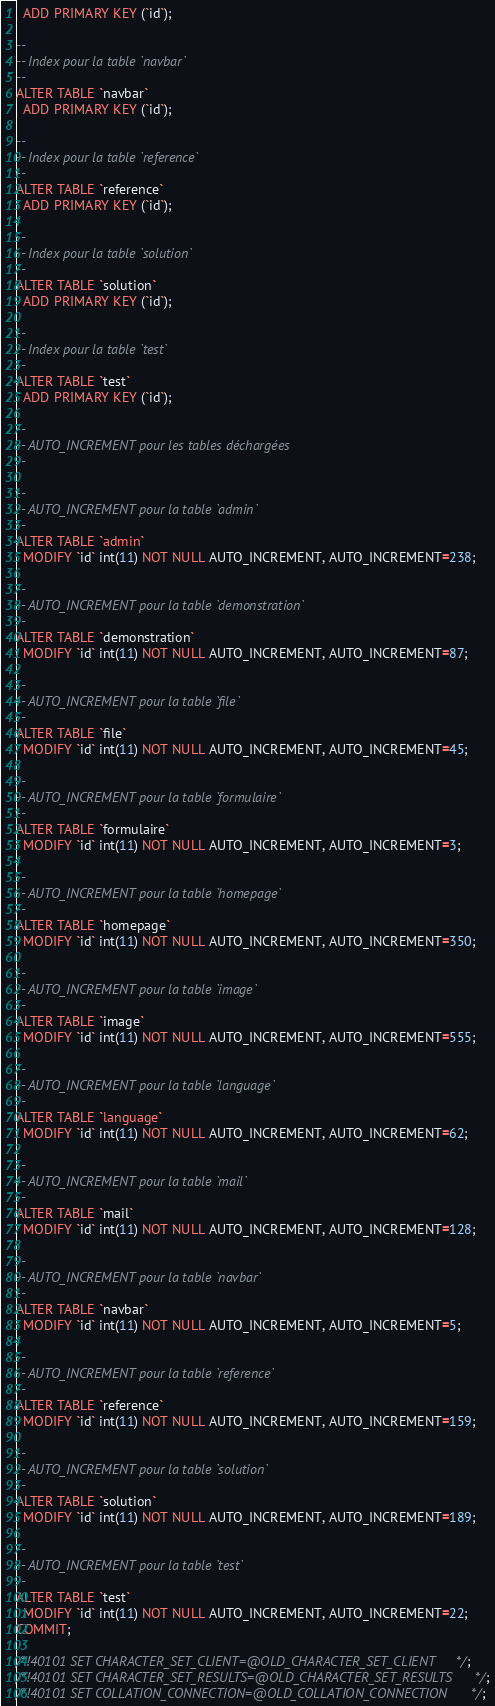<code> <loc_0><loc_0><loc_500><loc_500><_SQL_>  ADD PRIMARY KEY (`id`);

--
-- Index pour la table `navbar`
--
ALTER TABLE `navbar`
  ADD PRIMARY KEY (`id`);

--
-- Index pour la table `reference`
--
ALTER TABLE `reference`
  ADD PRIMARY KEY (`id`);

--
-- Index pour la table `solution`
--
ALTER TABLE `solution`
  ADD PRIMARY KEY (`id`);

--
-- Index pour la table `test`
--
ALTER TABLE `test`
  ADD PRIMARY KEY (`id`);

--
-- AUTO_INCREMENT pour les tables déchargées
--

--
-- AUTO_INCREMENT pour la table `admin`
--
ALTER TABLE `admin`
  MODIFY `id` int(11) NOT NULL AUTO_INCREMENT, AUTO_INCREMENT=238;

--
-- AUTO_INCREMENT pour la table `demonstration`
--
ALTER TABLE `demonstration`
  MODIFY `id` int(11) NOT NULL AUTO_INCREMENT, AUTO_INCREMENT=87;

--
-- AUTO_INCREMENT pour la table `file`
--
ALTER TABLE `file`
  MODIFY `id` int(11) NOT NULL AUTO_INCREMENT, AUTO_INCREMENT=45;

--
-- AUTO_INCREMENT pour la table `formulaire`
--
ALTER TABLE `formulaire`
  MODIFY `id` int(11) NOT NULL AUTO_INCREMENT, AUTO_INCREMENT=3;

--
-- AUTO_INCREMENT pour la table `homepage`
--
ALTER TABLE `homepage`
  MODIFY `id` int(11) NOT NULL AUTO_INCREMENT, AUTO_INCREMENT=350;

--
-- AUTO_INCREMENT pour la table `image`
--
ALTER TABLE `image`
  MODIFY `id` int(11) NOT NULL AUTO_INCREMENT, AUTO_INCREMENT=555;

--
-- AUTO_INCREMENT pour la table `language`
--
ALTER TABLE `language`
  MODIFY `id` int(11) NOT NULL AUTO_INCREMENT, AUTO_INCREMENT=62;

--
-- AUTO_INCREMENT pour la table `mail`
--
ALTER TABLE `mail`
  MODIFY `id` int(11) NOT NULL AUTO_INCREMENT, AUTO_INCREMENT=128;

--
-- AUTO_INCREMENT pour la table `navbar`
--
ALTER TABLE `navbar`
  MODIFY `id` int(11) NOT NULL AUTO_INCREMENT, AUTO_INCREMENT=5;

--
-- AUTO_INCREMENT pour la table `reference`
--
ALTER TABLE `reference`
  MODIFY `id` int(11) NOT NULL AUTO_INCREMENT, AUTO_INCREMENT=159;

--
-- AUTO_INCREMENT pour la table `solution`
--
ALTER TABLE `solution`
  MODIFY `id` int(11) NOT NULL AUTO_INCREMENT, AUTO_INCREMENT=189;

--
-- AUTO_INCREMENT pour la table `test`
--
ALTER TABLE `test`
  MODIFY `id` int(11) NOT NULL AUTO_INCREMENT, AUTO_INCREMENT=22;
COMMIT;

/*!40101 SET CHARACTER_SET_CLIENT=@OLD_CHARACTER_SET_CLIENT */;
/*!40101 SET CHARACTER_SET_RESULTS=@OLD_CHARACTER_SET_RESULTS */;
/*!40101 SET COLLATION_CONNECTION=@OLD_COLLATION_CONNECTION */;
</code> 